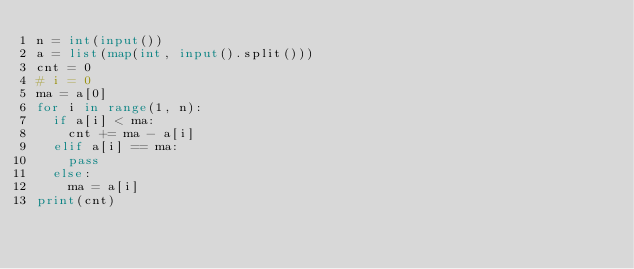Convert code to text. <code><loc_0><loc_0><loc_500><loc_500><_Python_>n = int(input())
a = list(map(int, input().split()))
cnt = 0
# i = 0
ma = a[0]
for i in range(1, n):
  if a[i] < ma:
    cnt += ma - a[i]
  elif a[i] == ma:
    pass
  else:
    ma = a[i]
print(cnt)</code> 